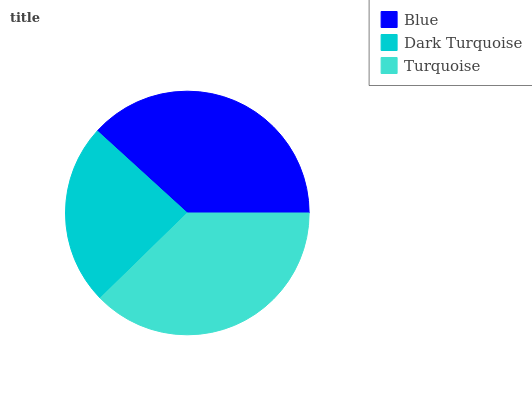Is Dark Turquoise the minimum?
Answer yes or no. Yes. Is Blue the maximum?
Answer yes or no. Yes. Is Turquoise the minimum?
Answer yes or no. No. Is Turquoise the maximum?
Answer yes or no. No. Is Turquoise greater than Dark Turquoise?
Answer yes or no. Yes. Is Dark Turquoise less than Turquoise?
Answer yes or no. Yes. Is Dark Turquoise greater than Turquoise?
Answer yes or no. No. Is Turquoise less than Dark Turquoise?
Answer yes or no. No. Is Turquoise the high median?
Answer yes or no. Yes. Is Turquoise the low median?
Answer yes or no. Yes. Is Blue the high median?
Answer yes or no. No. Is Dark Turquoise the low median?
Answer yes or no. No. 